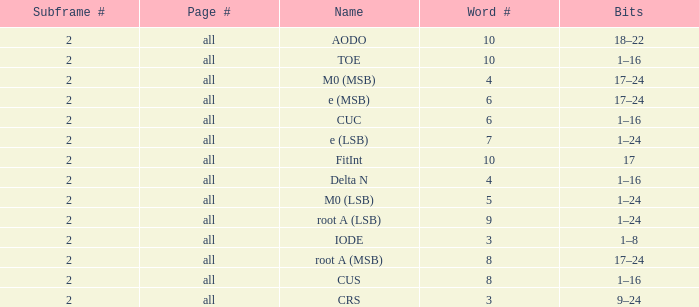What is the total subframe count with Bits of 18–22? 2.0. 